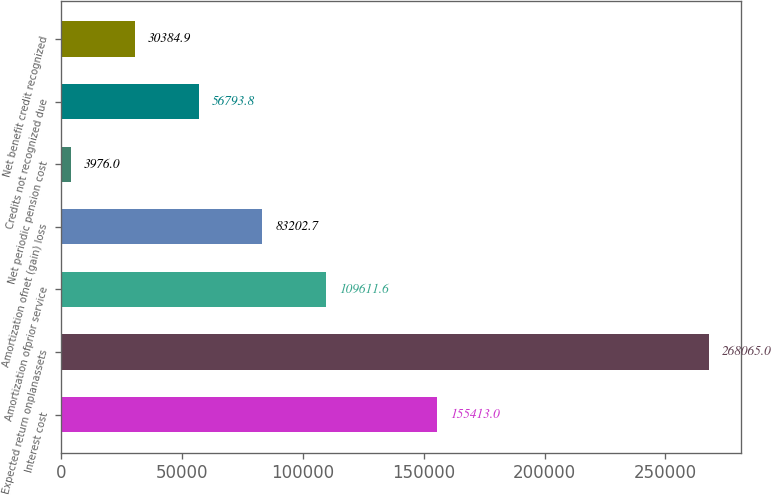<chart> <loc_0><loc_0><loc_500><loc_500><bar_chart><fcel>Interest cost<fcel>Expected return onplanassets<fcel>Amortization ofprior service<fcel>Amortization ofnet (gain) loss<fcel>Net periodic pension cost<fcel>Credits not recognized due<fcel>Net benefit credit recognized<nl><fcel>155413<fcel>268065<fcel>109612<fcel>83202.7<fcel>3976<fcel>56793.8<fcel>30384.9<nl></chart> 